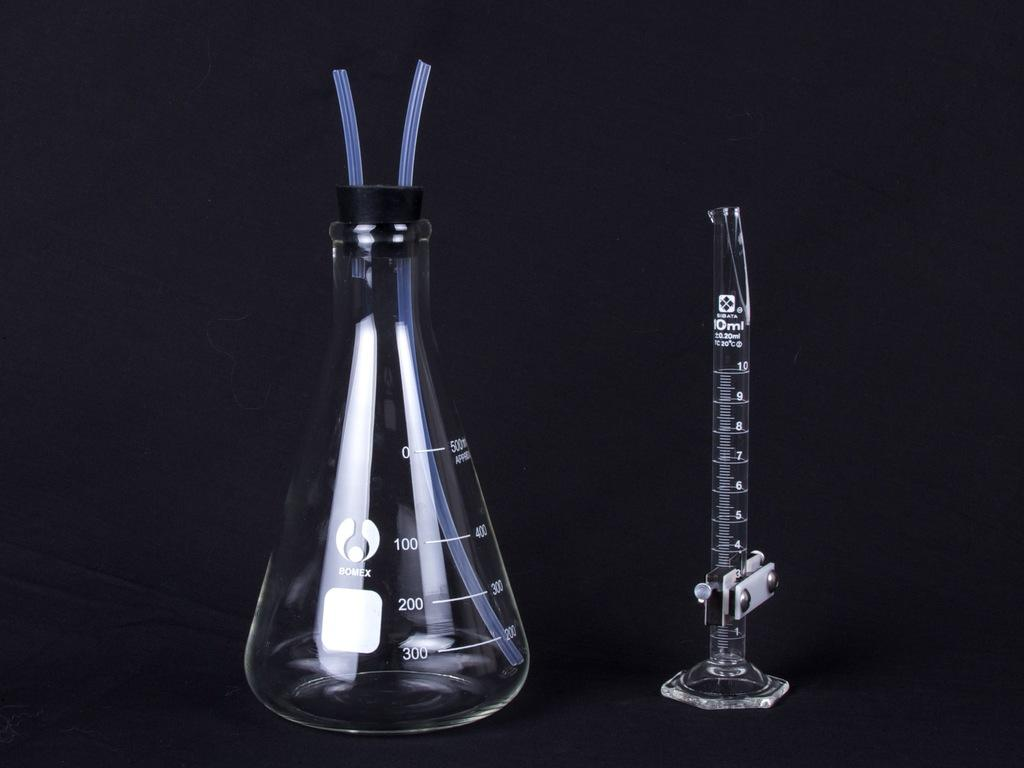Provide a one-sentence caption for the provided image. A beaker that measures up to 500 ml and a test tube sit side by side. 